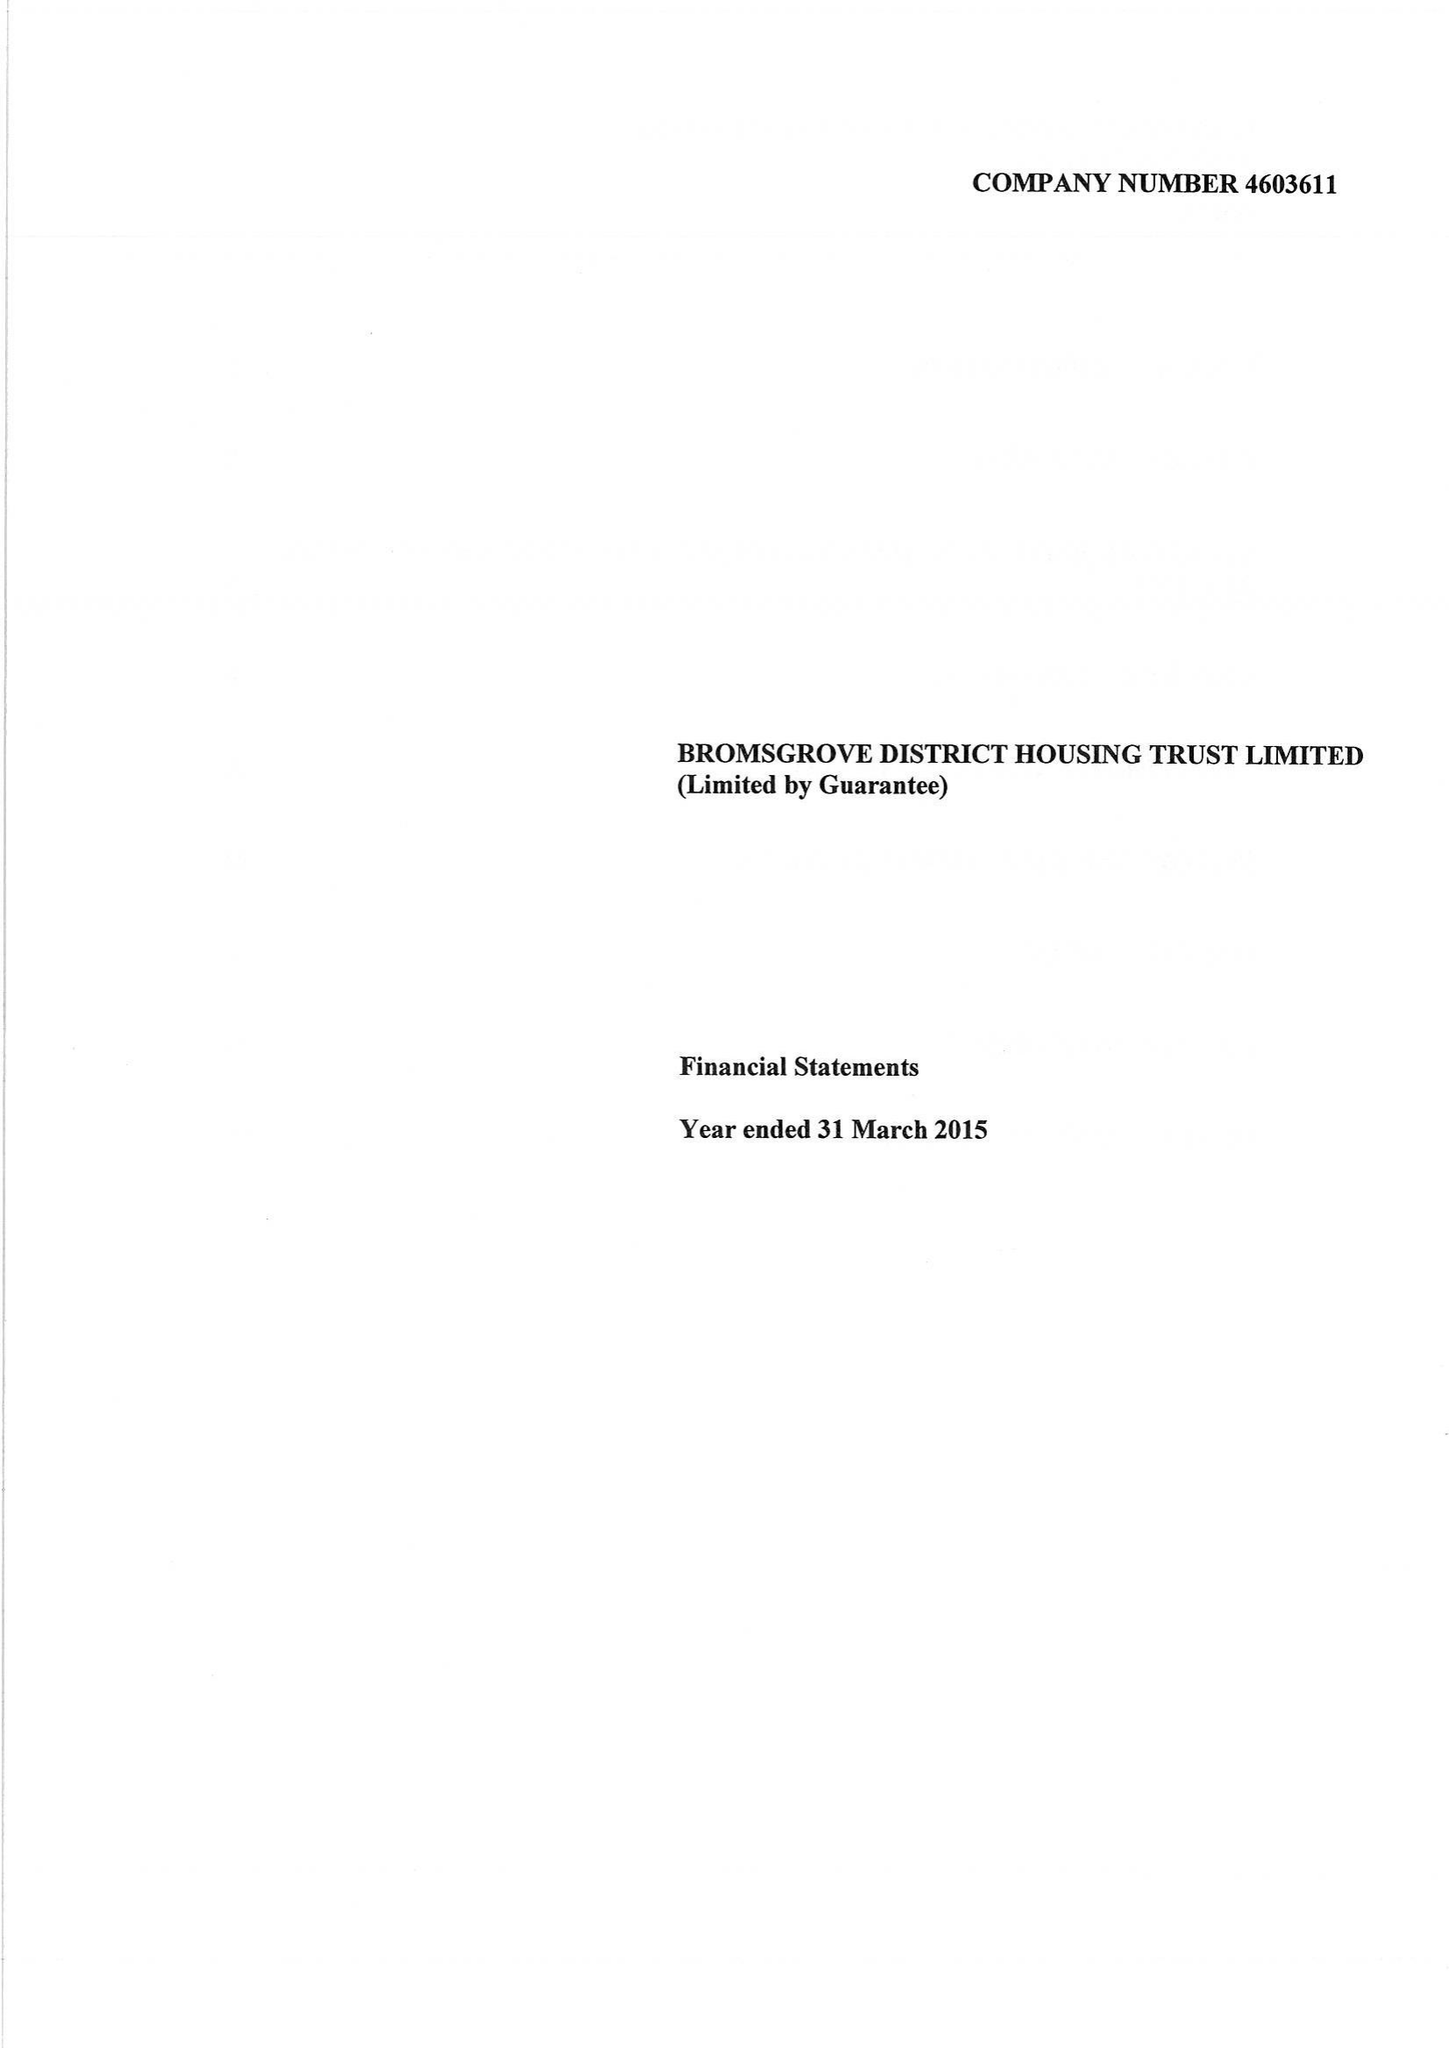What is the value for the charity_name?
Answer the question using a single word or phrase. Bromsgrove District Housing Trust Ltd. 